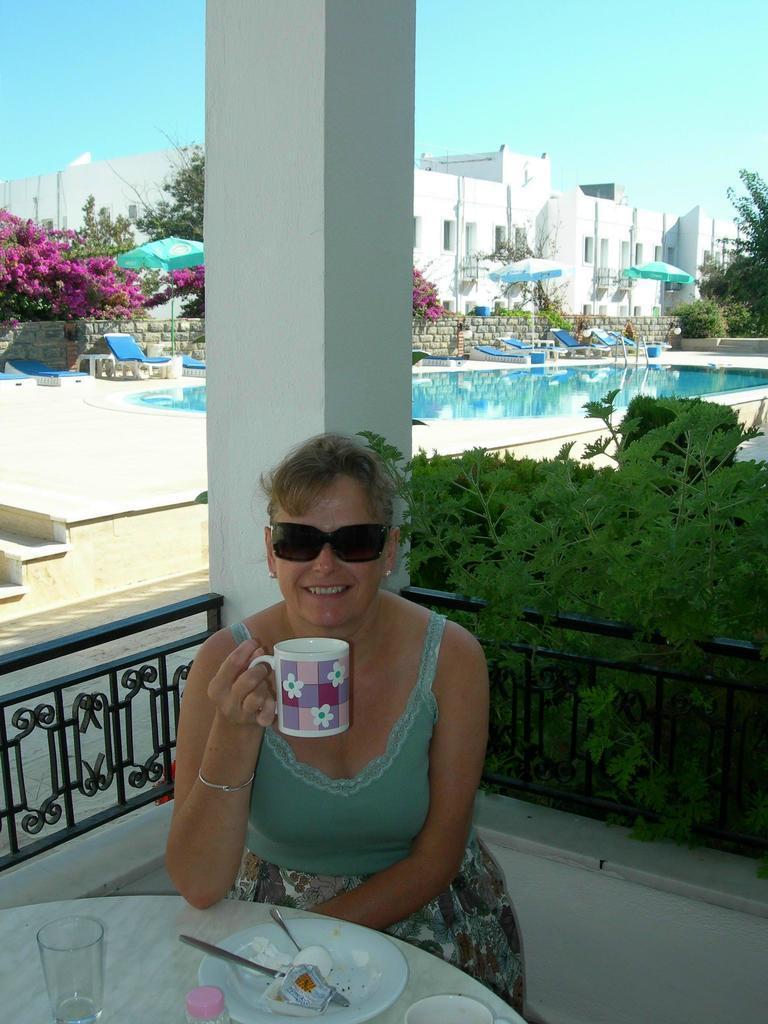Describe this image in one or two sentences. In the picture there is a woman posing for the photo, she is sitting in front of a table and holding a cup with her hand and on the table there is some food and a glass, behind the woman there is a pool, few trees and behind the trees there is a building. 